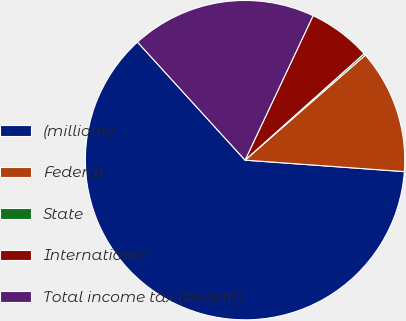<chart> <loc_0><loc_0><loc_500><loc_500><pie_chart><fcel>(millions)<fcel>Federal<fcel>State<fcel>International<fcel>Total income tax (benefit)<nl><fcel>62.09%<fcel>12.57%<fcel>0.19%<fcel>6.38%<fcel>18.76%<nl></chart> 